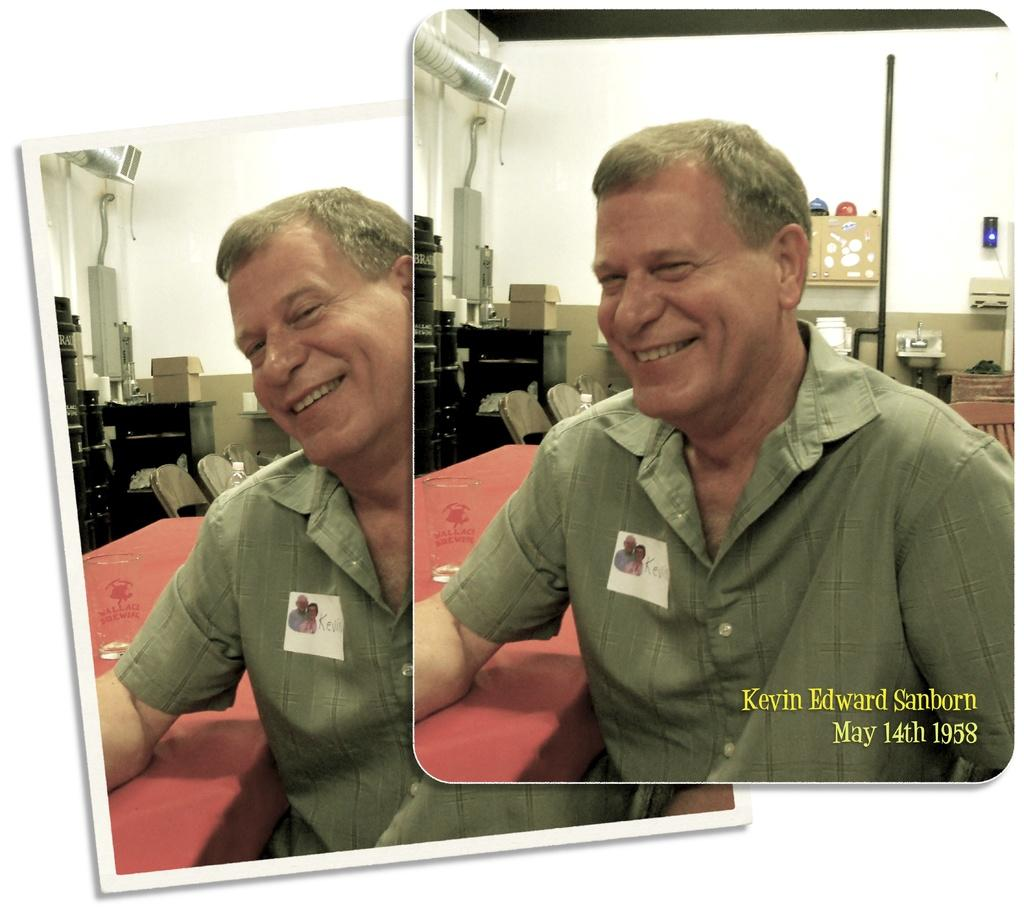What is the main subject of the image? There is a person in the image. What is the person doing in the image? The person is sitting. What is the person's facial expression in the image? The person is smiling. What else can be seen in the image besides the person? There are other objects in the image. Where is the text located in the image? The text is written in the right corner of the image. What type of arithmetic problem is the person solving in the image? There is no arithmetic problem visible in the image. What does the person's dad think about their smile in the image? The person's dad is not present in the image, so it is impossible to know their opinion about the person's smile. 